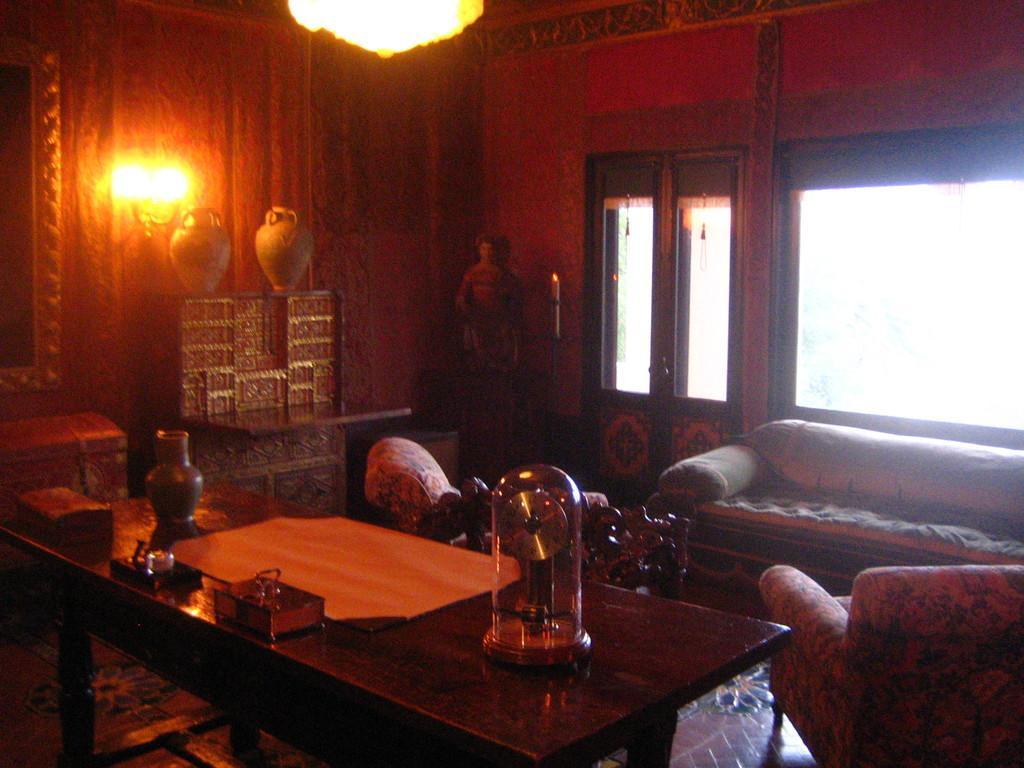Could you give a brief overview of what you see in this image? This picture is clicked inside the room. On the right bottom of the picture, we see sofa and sofa chair. In front of the picture, we see a table on which a pot, book and glass are placed on it. Behind that, we see a cupboard with two points on it and behind that we see a curtain and a light. On the right side of the picture, we see a door and beside that a window. 